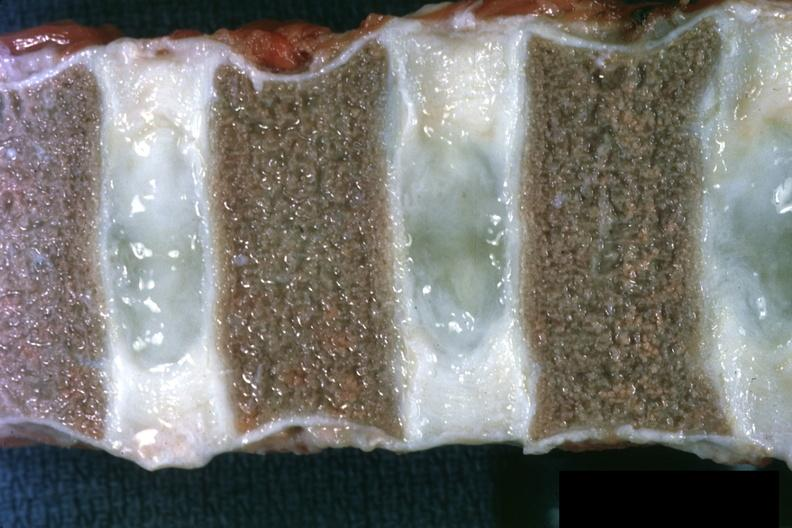where is marrow in?
Answer the question using a single word or phrase. Bone 